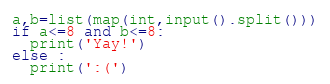Convert code to text. <code><loc_0><loc_0><loc_500><loc_500><_Python_>a,b=list(map(int,input().split()))
if a<=8 and b<=8:
  print('Yay!')
else :
  print(':(')</code> 